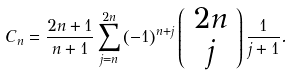<formula> <loc_0><loc_0><loc_500><loc_500>C _ { n } = \frac { 2 n + 1 } { n + 1 } \sum _ { j = n } ^ { 2 n } \left ( - 1 \right ) ^ { n + j } \left ( \begin{array} { c } 2 n \\ j \end{array} \right ) \frac { 1 } { j + 1 } .</formula> 